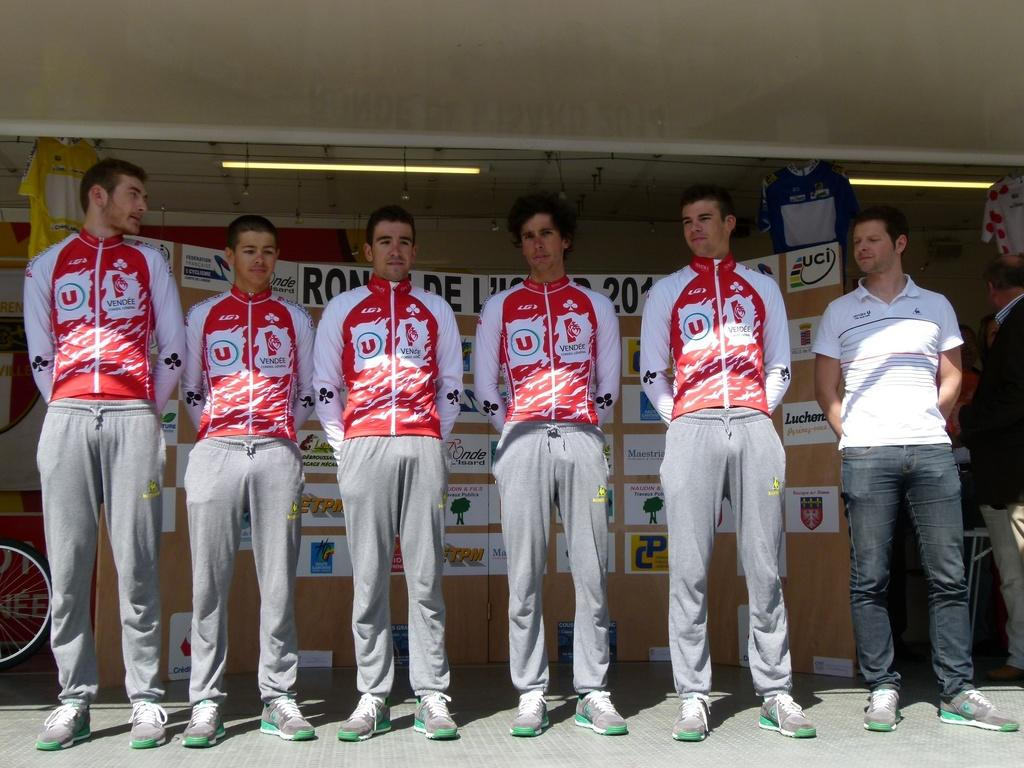<image>
Describe the image concisely. A line up of men in red and white and the word vendee on their tops. 